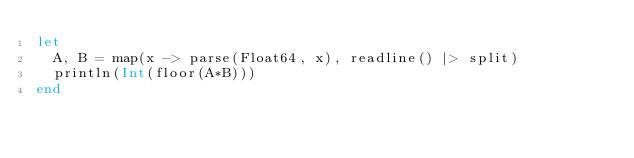<code> <loc_0><loc_0><loc_500><loc_500><_Julia_>let
  A, B = map(x -> parse(Float64, x), readline() |> split)
  println(Int(floor(A*B)))
end
</code> 